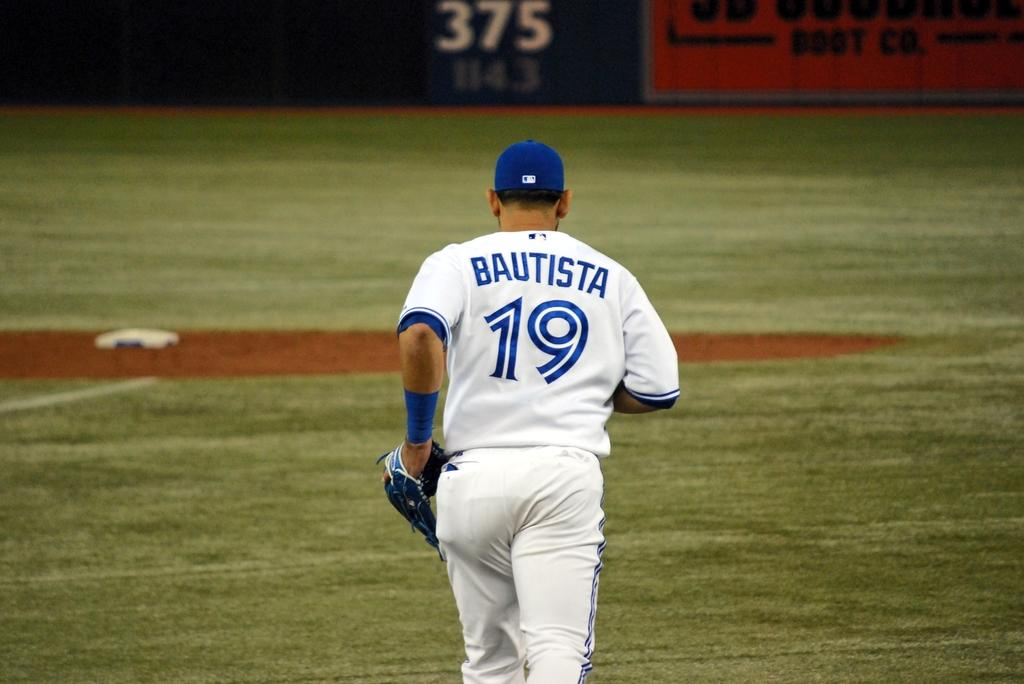<image>
Give a short and clear explanation of the subsequent image. A man wearing a number 19 baseball uniform that says Bautista on the back runs on a baseball field. 